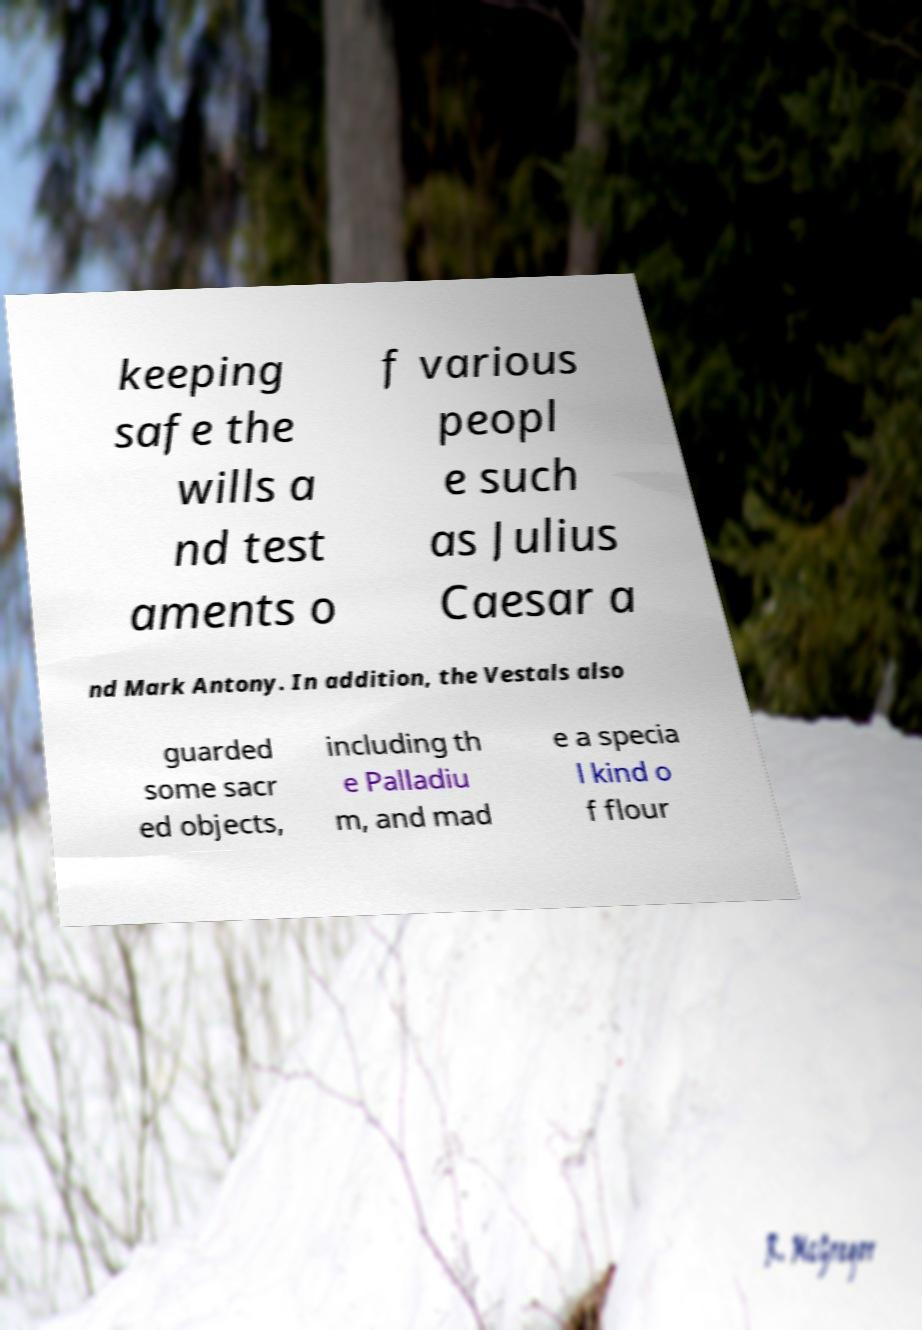Please identify and transcribe the text found in this image. keeping safe the wills a nd test aments o f various peopl e such as Julius Caesar a nd Mark Antony. In addition, the Vestals also guarded some sacr ed objects, including th e Palladiu m, and mad e a specia l kind o f flour 